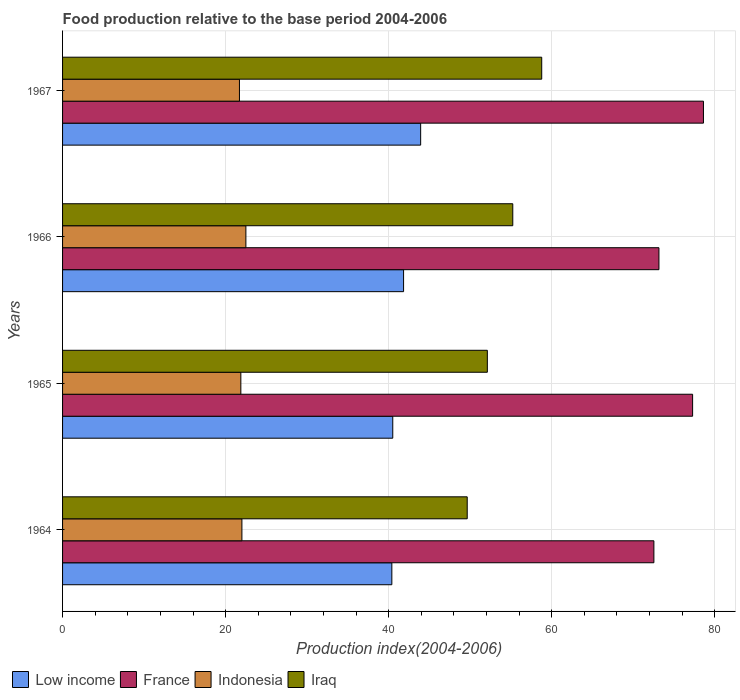How many different coloured bars are there?
Offer a terse response. 4. How many groups of bars are there?
Keep it short and to the point. 4. Are the number of bars per tick equal to the number of legend labels?
Ensure brevity in your answer.  Yes. What is the label of the 1st group of bars from the top?
Offer a terse response. 1967. In how many cases, is the number of bars for a given year not equal to the number of legend labels?
Your answer should be very brief. 0. What is the food production index in France in 1966?
Ensure brevity in your answer.  73.16. Across all years, what is the maximum food production index in Indonesia?
Provide a short and direct response. 22.49. Across all years, what is the minimum food production index in Low income?
Provide a succinct answer. 40.39. In which year was the food production index in Indonesia maximum?
Your response must be concise. 1966. In which year was the food production index in France minimum?
Provide a succinct answer. 1964. What is the total food production index in France in the graph?
Your answer should be very brief. 301.61. What is the difference between the food production index in Iraq in 1966 and that in 1967?
Offer a very short reply. -3.55. What is the difference between the food production index in Indonesia in 1964 and the food production index in France in 1965?
Ensure brevity in your answer.  -55.29. What is the average food production index in Low income per year?
Provide a succinct answer. 41.67. In the year 1965, what is the difference between the food production index in France and food production index in Low income?
Ensure brevity in your answer.  36.78. What is the ratio of the food production index in Iraq in 1964 to that in 1965?
Provide a short and direct response. 0.95. What is the difference between the highest and the second highest food production index in France?
Your answer should be compact. 1.33. What is the difference between the highest and the lowest food production index in Indonesia?
Your answer should be very brief. 0.79. In how many years, is the food production index in France greater than the average food production index in France taken over all years?
Ensure brevity in your answer.  2. Is the sum of the food production index in Indonesia in 1964 and 1965 greater than the maximum food production index in Low income across all years?
Your answer should be compact. No. Is it the case that in every year, the sum of the food production index in Iraq and food production index in Low income is greater than the sum of food production index in Indonesia and food production index in France?
Offer a terse response. Yes. What does the 3rd bar from the bottom in 1965 represents?
Offer a terse response. Indonesia. Is it the case that in every year, the sum of the food production index in Iraq and food production index in Low income is greater than the food production index in France?
Keep it short and to the point. Yes. Are all the bars in the graph horizontal?
Keep it short and to the point. Yes. How many years are there in the graph?
Your answer should be very brief. 4. What is the difference between two consecutive major ticks on the X-axis?
Your answer should be compact. 20. Are the values on the major ticks of X-axis written in scientific E-notation?
Ensure brevity in your answer.  No. Does the graph contain any zero values?
Your answer should be compact. No. Where does the legend appear in the graph?
Your answer should be compact. Bottom left. How many legend labels are there?
Keep it short and to the point. 4. How are the legend labels stacked?
Your response must be concise. Horizontal. What is the title of the graph?
Give a very brief answer. Food production relative to the base period 2004-2006. Does "Gambia, The" appear as one of the legend labels in the graph?
Your response must be concise. No. What is the label or title of the X-axis?
Offer a very short reply. Production index(2004-2006). What is the Production index(2004-2006) of Low income in 1964?
Provide a short and direct response. 40.39. What is the Production index(2004-2006) of France in 1964?
Provide a succinct answer. 72.54. What is the Production index(2004-2006) in Indonesia in 1964?
Provide a short and direct response. 22. What is the Production index(2004-2006) of Iraq in 1964?
Your response must be concise. 49.64. What is the Production index(2004-2006) of Low income in 1965?
Your response must be concise. 40.51. What is the Production index(2004-2006) of France in 1965?
Offer a terse response. 77.29. What is the Production index(2004-2006) in Indonesia in 1965?
Provide a short and direct response. 21.87. What is the Production index(2004-2006) of Iraq in 1965?
Ensure brevity in your answer.  52.11. What is the Production index(2004-2006) of Low income in 1966?
Offer a very short reply. 41.83. What is the Production index(2004-2006) in France in 1966?
Your response must be concise. 73.16. What is the Production index(2004-2006) in Indonesia in 1966?
Make the answer very short. 22.49. What is the Production index(2004-2006) in Iraq in 1966?
Ensure brevity in your answer.  55.23. What is the Production index(2004-2006) of Low income in 1967?
Your answer should be very brief. 43.93. What is the Production index(2004-2006) in France in 1967?
Give a very brief answer. 78.62. What is the Production index(2004-2006) of Indonesia in 1967?
Ensure brevity in your answer.  21.7. What is the Production index(2004-2006) in Iraq in 1967?
Your answer should be compact. 58.78. Across all years, what is the maximum Production index(2004-2006) in Low income?
Keep it short and to the point. 43.93. Across all years, what is the maximum Production index(2004-2006) in France?
Your response must be concise. 78.62. Across all years, what is the maximum Production index(2004-2006) of Indonesia?
Provide a succinct answer. 22.49. Across all years, what is the maximum Production index(2004-2006) in Iraq?
Offer a terse response. 58.78. Across all years, what is the minimum Production index(2004-2006) in Low income?
Provide a short and direct response. 40.39. Across all years, what is the minimum Production index(2004-2006) of France?
Give a very brief answer. 72.54. Across all years, what is the minimum Production index(2004-2006) in Indonesia?
Ensure brevity in your answer.  21.7. Across all years, what is the minimum Production index(2004-2006) of Iraq?
Offer a terse response. 49.64. What is the total Production index(2004-2006) in Low income in the graph?
Make the answer very short. 166.66. What is the total Production index(2004-2006) in France in the graph?
Offer a very short reply. 301.61. What is the total Production index(2004-2006) in Indonesia in the graph?
Offer a very short reply. 88.06. What is the total Production index(2004-2006) of Iraq in the graph?
Ensure brevity in your answer.  215.76. What is the difference between the Production index(2004-2006) of Low income in 1964 and that in 1965?
Make the answer very short. -0.11. What is the difference between the Production index(2004-2006) of France in 1964 and that in 1965?
Your answer should be very brief. -4.75. What is the difference between the Production index(2004-2006) of Indonesia in 1964 and that in 1965?
Ensure brevity in your answer.  0.13. What is the difference between the Production index(2004-2006) in Iraq in 1964 and that in 1965?
Keep it short and to the point. -2.47. What is the difference between the Production index(2004-2006) in Low income in 1964 and that in 1966?
Give a very brief answer. -1.44. What is the difference between the Production index(2004-2006) of France in 1964 and that in 1966?
Make the answer very short. -0.62. What is the difference between the Production index(2004-2006) of Indonesia in 1964 and that in 1966?
Offer a terse response. -0.49. What is the difference between the Production index(2004-2006) of Iraq in 1964 and that in 1966?
Make the answer very short. -5.59. What is the difference between the Production index(2004-2006) in Low income in 1964 and that in 1967?
Your answer should be very brief. -3.53. What is the difference between the Production index(2004-2006) of France in 1964 and that in 1967?
Offer a very short reply. -6.08. What is the difference between the Production index(2004-2006) in Indonesia in 1964 and that in 1967?
Make the answer very short. 0.3. What is the difference between the Production index(2004-2006) in Iraq in 1964 and that in 1967?
Ensure brevity in your answer.  -9.14. What is the difference between the Production index(2004-2006) of Low income in 1965 and that in 1966?
Your response must be concise. -1.33. What is the difference between the Production index(2004-2006) in France in 1965 and that in 1966?
Make the answer very short. 4.13. What is the difference between the Production index(2004-2006) of Indonesia in 1965 and that in 1966?
Make the answer very short. -0.62. What is the difference between the Production index(2004-2006) of Iraq in 1965 and that in 1966?
Your response must be concise. -3.12. What is the difference between the Production index(2004-2006) of Low income in 1965 and that in 1967?
Keep it short and to the point. -3.42. What is the difference between the Production index(2004-2006) in France in 1965 and that in 1967?
Provide a short and direct response. -1.33. What is the difference between the Production index(2004-2006) in Indonesia in 1965 and that in 1967?
Give a very brief answer. 0.17. What is the difference between the Production index(2004-2006) of Iraq in 1965 and that in 1967?
Ensure brevity in your answer.  -6.67. What is the difference between the Production index(2004-2006) in Low income in 1966 and that in 1967?
Your response must be concise. -2.09. What is the difference between the Production index(2004-2006) in France in 1966 and that in 1967?
Give a very brief answer. -5.46. What is the difference between the Production index(2004-2006) in Indonesia in 1966 and that in 1967?
Offer a very short reply. 0.79. What is the difference between the Production index(2004-2006) of Iraq in 1966 and that in 1967?
Your response must be concise. -3.55. What is the difference between the Production index(2004-2006) in Low income in 1964 and the Production index(2004-2006) in France in 1965?
Give a very brief answer. -36.9. What is the difference between the Production index(2004-2006) of Low income in 1964 and the Production index(2004-2006) of Indonesia in 1965?
Ensure brevity in your answer.  18.52. What is the difference between the Production index(2004-2006) of Low income in 1964 and the Production index(2004-2006) of Iraq in 1965?
Offer a terse response. -11.72. What is the difference between the Production index(2004-2006) in France in 1964 and the Production index(2004-2006) in Indonesia in 1965?
Make the answer very short. 50.67. What is the difference between the Production index(2004-2006) of France in 1964 and the Production index(2004-2006) of Iraq in 1965?
Your answer should be compact. 20.43. What is the difference between the Production index(2004-2006) of Indonesia in 1964 and the Production index(2004-2006) of Iraq in 1965?
Make the answer very short. -30.11. What is the difference between the Production index(2004-2006) in Low income in 1964 and the Production index(2004-2006) in France in 1966?
Your response must be concise. -32.77. What is the difference between the Production index(2004-2006) in Low income in 1964 and the Production index(2004-2006) in Indonesia in 1966?
Your answer should be very brief. 17.9. What is the difference between the Production index(2004-2006) of Low income in 1964 and the Production index(2004-2006) of Iraq in 1966?
Offer a very short reply. -14.84. What is the difference between the Production index(2004-2006) of France in 1964 and the Production index(2004-2006) of Indonesia in 1966?
Provide a succinct answer. 50.05. What is the difference between the Production index(2004-2006) of France in 1964 and the Production index(2004-2006) of Iraq in 1966?
Keep it short and to the point. 17.31. What is the difference between the Production index(2004-2006) of Indonesia in 1964 and the Production index(2004-2006) of Iraq in 1966?
Your answer should be compact. -33.23. What is the difference between the Production index(2004-2006) of Low income in 1964 and the Production index(2004-2006) of France in 1967?
Your answer should be very brief. -38.23. What is the difference between the Production index(2004-2006) of Low income in 1964 and the Production index(2004-2006) of Indonesia in 1967?
Provide a succinct answer. 18.69. What is the difference between the Production index(2004-2006) of Low income in 1964 and the Production index(2004-2006) of Iraq in 1967?
Offer a terse response. -18.39. What is the difference between the Production index(2004-2006) in France in 1964 and the Production index(2004-2006) in Indonesia in 1967?
Your response must be concise. 50.84. What is the difference between the Production index(2004-2006) of France in 1964 and the Production index(2004-2006) of Iraq in 1967?
Offer a very short reply. 13.76. What is the difference between the Production index(2004-2006) in Indonesia in 1964 and the Production index(2004-2006) in Iraq in 1967?
Make the answer very short. -36.78. What is the difference between the Production index(2004-2006) of Low income in 1965 and the Production index(2004-2006) of France in 1966?
Give a very brief answer. -32.65. What is the difference between the Production index(2004-2006) in Low income in 1965 and the Production index(2004-2006) in Indonesia in 1966?
Give a very brief answer. 18.02. What is the difference between the Production index(2004-2006) of Low income in 1965 and the Production index(2004-2006) of Iraq in 1966?
Ensure brevity in your answer.  -14.72. What is the difference between the Production index(2004-2006) of France in 1965 and the Production index(2004-2006) of Indonesia in 1966?
Make the answer very short. 54.8. What is the difference between the Production index(2004-2006) of France in 1965 and the Production index(2004-2006) of Iraq in 1966?
Provide a succinct answer. 22.06. What is the difference between the Production index(2004-2006) in Indonesia in 1965 and the Production index(2004-2006) in Iraq in 1966?
Provide a short and direct response. -33.36. What is the difference between the Production index(2004-2006) of Low income in 1965 and the Production index(2004-2006) of France in 1967?
Offer a very short reply. -38.11. What is the difference between the Production index(2004-2006) in Low income in 1965 and the Production index(2004-2006) in Indonesia in 1967?
Provide a succinct answer. 18.81. What is the difference between the Production index(2004-2006) in Low income in 1965 and the Production index(2004-2006) in Iraq in 1967?
Make the answer very short. -18.27. What is the difference between the Production index(2004-2006) of France in 1965 and the Production index(2004-2006) of Indonesia in 1967?
Your answer should be very brief. 55.59. What is the difference between the Production index(2004-2006) of France in 1965 and the Production index(2004-2006) of Iraq in 1967?
Your answer should be compact. 18.51. What is the difference between the Production index(2004-2006) in Indonesia in 1965 and the Production index(2004-2006) in Iraq in 1967?
Give a very brief answer. -36.91. What is the difference between the Production index(2004-2006) of Low income in 1966 and the Production index(2004-2006) of France in 1967?
Provide a short and direct response. -36.79. What is the difference between the Production index(2004-2006) of Low income in 1966 and the Production index(2004-2006) of Indonesia in 1967?
Make the answer very short. 20.13. What is the difference between the Production index(2004-2006) in Low income in 1966 and the Production index(2004-2006) in Iraq in 1967?
Make the answer very short. -16.95. What is the difference between the Production index(2004-2006) of France in 1966 and the Production index(2004-2006) of Indonesia in 1967?
Offer a terse response. 51.46. What is the difference between the Production index(2004-2006) of France in 1966 and the Production index(2004-2006) of Iraq in 1967?
Your response must be concise. 14.38. What is the difference between the Production index(2004-2006) in Indonesia in 1966 and the Production index(2004-2006) in Iraq in 1967?
Ensure brevity in your answer.  -36.29. What is the average Production index(2004-2006) of Low income per year?
Offer a very short reply. 41.67. What is the average Production index(2004-2006) in France per year?
Give a very brief answer. 75.4. What is the average Production index(2004-2006) in Indonesia per year?
Offer a terse response. 22.02. What is the average Production index(2004-2006) of Iraq per year?
Your answer should be very brief. 53.94. In the year 1964, what is the difference between the Production index(2004-2006) of Low income and Production index(2004-2006) of France?
Keep it short and to the point. -32.15. In the year 1964, what is the difference between the Production index(2004-2006) in Low income and Production index(2004-2006) in Indonesia?
Ensure brevity in your answer.  18.39. In the year 1964, what is the difference between the Production index(2004-2006) in Low income and Production index(2004-2006) in Iraq?
Provide a short and direct response. -9.25. In the year 1964, what is the difference between the Production index(2004-2006) in France and Production index(2004-2006) in Indonesia?
Your response must be concise. 50.54. In the year 1964, what is the difference between the Production index(2004-2006) of France and Production index(2004-2006) of Iraq?
Keep it short and to the point. 22.9. In the year 1964, what is the difference between the Production index(2004-2006) of Indonesia and Production index(2004-2006) of Iraq?
Your answer should be very brief. -27.64. In the year 1965, what is the difference between the Production index(2004-2006) of Low income and Production index(2004-2006) of France?
Your answer should be very brief. -36.78. In the year 1965, what is the difference between the Production index(2004-2006) of Low income and Production index(2004-2006) of Indonesia?
Your answer should be compact. 18.64. In the year 1965, what is the difference between the Production index(2004-2006) of Low income and Production index(2004-2006) of Iraq?
Give a very brief answer. -11.6. In the year 1965, what is the difference between the Production index(2004-2006) of France and Production index(2004-2006) of Indonesia?
Your response must be concise. 55.42. In the year 1965, what is the difference between the Production index(2004-2006) in France and Production index(2004-2006) in Iraq?
Your response must be concise. 25.18. In the year 1965, what is the difference between the Production index(2004-2006) in Indonesia and Production index(2004-2006) in Iraq?
Provide a short and direct response. -30.24. In the year 1966, what is the difference between the Production index(2004-2006) of Low income and Production index(2004-2006) of France?
Offer a terse response. -31.33. In the year 1966, what is the difference between the Production index(2004-2006) in Low income and Production index(2004-2006) in Indonesia?
Make the answer very short. 19.34. In the year 1966, what is the difference between the Production index(2004-2006) of Low income and Production index(2004-2006) of Iraq?
Offer a terse response. -13.4. In the year 1966, what is the difference between the Production index(2004-2006) in France and Production index(2004-2006) in Indonesia?
Keep it short and to the point. 50.67. In the year 1966, what is the difference between the Production index(2004-2006) of France and Production index(2004-2006) of Iraq?
Your response must be concise. 17.93. In the year 1966, what is the difference between the Production index(2004-2006) in Indonesia and Production index(2004-2006) in Iraq?
Offer a terse response. -32.74. In the year 1967, what is the difference between the Production index(2004-2006) of Low income and Production index(2004-2006) of France?
Provide a succinct answer. -34.69. In the year 1967, what is the difference between the Production index(2004-2006) in Low income and Production index(2004-2006) in Indonesia?
Provide a succinct answer. 22.23. In the year 1967, what is the difference between the Production index(2004-2006) in Low income and Production index(2004-2006) in Iraq?
Keep it short and to the point. -14.85. In the year 1967, what is the difference between the Production index(2004-2006) in France and Production index(2004-2006) in Indonesia?
Offer a terse response. 56.92. In the year 1967, what is the difference between the Production index(2004-2006) in France and Production index(2004-2006) in Iraq?
Your response must be concise. 19.84. In the year 1967, what is the difference between the Production index(2004-2006) in Indonesia and Production index(2004-2006) in Iraq?
Provide a short and direct response. -37.08. What is the ratio of the Production index(2004-2006) in France in 1964 to that in 1965?
Provide a succinct answer. 0.94. What is the ratio of the Production index(2004-2006) in Indonesia in 1964 to that in 1965?
Provide a short and direct response. 1.01. What is the ratio of the Production index(2004-2006) in Iraq in 1964 to that in 1965?
Offer a terse response. 0.95. What is the ratio of the Production index(2004-2006) in Low income in 1964 to that in 1966?
Your response must be concise. 0.97. What is the ratio of the Production index(2004-2006) of France in 1964 to that in 1966?
Give a very brief answer. 0.99. What is the ratio of the Production index(2004-2006) in Indonesia in 1964 to that in 1966?
Ensure brevity in your answer.  0.98. What is the ratio of the Production index(2004-2006) of Iraq in 1964 to that in 1966?
Your answer should be very brief. 0.9. What is the ratio of the Production index(2004-2006) in Low income in 1964 to that in 1967?
Your response must be concise. 0.92. What is the ratio of the Production index(2004-2006) of France in 1964 to that in 1967?
Keep it short and to the point. 0.92. What is the ratio of the Production index(2004-2006) of Indonesia in 1964 to that in 1967?
Offer a terse response. 1.01. What is the ratio of the Production index(2004-2006) of Iraq in 1964 to that in 1967?
Provide a succinct answer. 0.84. What is the ratio of the Production index(2004-2006) in Low income in 1965 to that in 1966?
Your response must be concise. 0.97. What is the ratio of the Production index(2004-2006) in France in 1965 to that in 1966?
Provide a short and direct response. 1.06. What is the ratio of the Production index(2004-2006) in Indonesia in 1965 to that in 1966?
Your answer should be compact. 0.97. What is the ratio of the Production index(2004-2006) in Iraq in 1965 to that in 1966?
Your answer should be very brief. 0.94. What is the ratio of the Production index(2004-2006) in Low income in 1965 to that in 1967?
Provide a succinct answer. 0.92. What is the ratio of the Production index(2004-2006) of France in 1965 to that in 1967?
Your answer should be very brief. 0.98. What is the ratio of the Production index(2004-2006) in Indonesia in 1965 to that in 1967?
Offer a very short reply. 1.01. What is the ratio of the Production index(2004-2006) of Iraq in 1965 to that in 1967?
Provide a succinct answer. 0.89. What is the ratio of the Production index(2004-2006) in Low income in 1966 to that in 1967?
Your answer should be very brief. 0.95. What is the ratio of the Production index(2004-2006) in France in 1966 to that in 1967?
Give a very brief answer. 0.93. What is the ratio of the Production index(2004-2006) in Indonesia in 1966 to that in 1967?
Your answer should be compact. 1.04. What is the ratio of the Production index(2004-2006) of Iraq in 1966 to that in 1967?
Provide a succinct answer. 0.94. What is the difference between the highest and the second highest Production index(2004-2006) in Low income?
Your answer should be compact. 2.09. What is the difference between the highest and the second highest Production index(2004-2006) of France?
Make the answer very short. 1.33. What is the difference between the highest and the second highest Production index(2004-2006) in Indonesia?
Provide a succinct answer. 0.49. What is the difference between the highest and the second highest Production index(2004-2006) of Iraq?
Ensure brevity in your answer.  3.55. What is the difference between the highest and the lowest Production index(2004-2006) in Low income?
Offer a very short reply. 3.53. What is the difference between the highest and the lowest Production index(2004-2006) of France?
Provide a short and direct response. 6.08. What is the difference between the highest and the lowest Production index(2004-2006) of Indonesia?
Offer a very short reply. 0.79. What is the difference between the highest and the lowest Production index(2004-2006) of Iraq?
Ensure brevity in your answer.  9.14. 